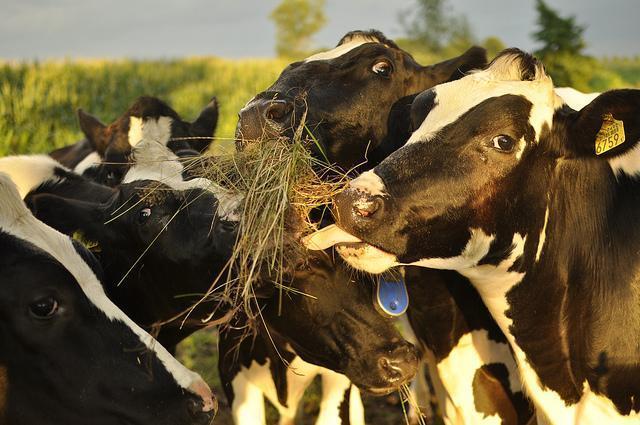How many cows have their tongue sticking out?
Give a very brief answer. 1. How many cows are in the image?
Give a very brief answer. 6. How many cows are there?
Give a very brief answer. 6. 